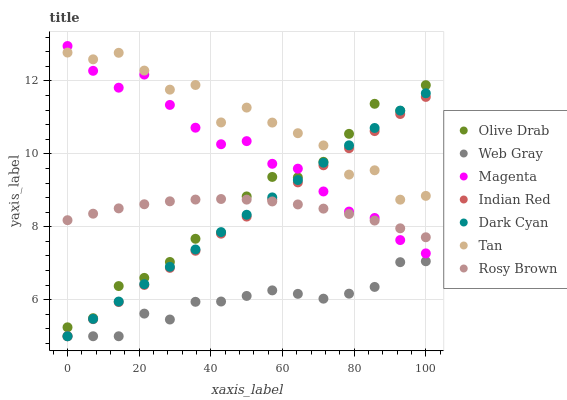Does Web Gray have the minimum area under the curve?
Answer yes or no. Yes. Does Tan have the maximum area under the curve?
Answer yes or no. Yes. Does Rosy Brown have the minimum area under the curve?
Answer yes or no. No. Does Rosy Brown have the maximum area under the curve?
Answer yes or no. No. Is Indian Red the smoothest?
Answer yes or no. Yes. Is Tan the roughest?
Answer yes or no. Yes. Is Rosy Brown the smoothest?
Answer yes or no. No. Is Rosy Brown the roughest?
Answer yes or no. No. Does Web Gray have the lowest value?
Answer yes or no. Yes. Does Rosy Brown have the lowest value?
Answer yes or no. No. Does Magenta have the highest value?
Answer yes or no. Yes. Does Rosy Brown have the highest value?
Answer yes or no. No. Is Web Gray less than Rosy Brown?
Answer yes or no. Yes. Is Tan greater than Web Gray?
Answer yes or no. Yes. Does Web Gray intersect Indian Red?
Answer yes or no. Yes. Is Web Gray less than Indian Red?
Answer yes or no. No. Is Web Gray greater than Indian Red?
Answer yes or no. No. Does Web Gray intersect Rosy Brown?
Answer yes or no. No. 